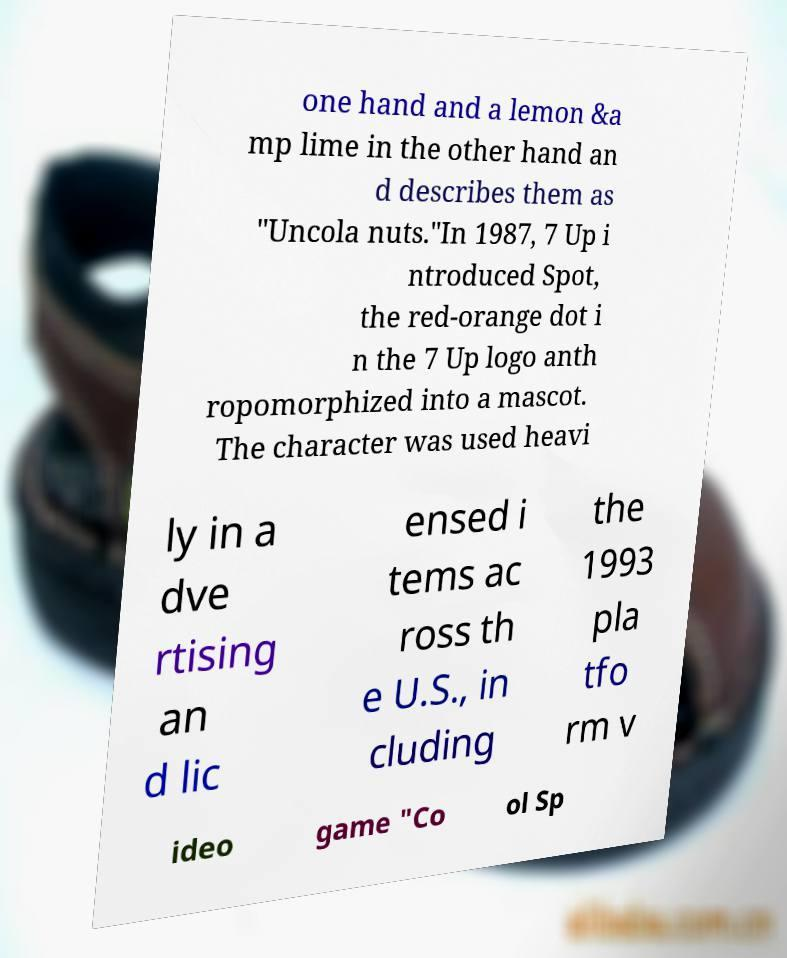Could you assist in decoding the text presented in this image and type it out clearly? one hand and a lemon &a mp lime in the other hand an d describes them as "Uncola nuts."In 1987, 7 Up i ntroduced Spot, the red-orange dot i n the 7 Up logo anth ropomorphized into a mascot. The character was used heavi ly in a dve rtising an d lic ensed i tems ac ross th e U.S., in cluding the 1993 pla tfo rm v ideo game "Co ol Sp 